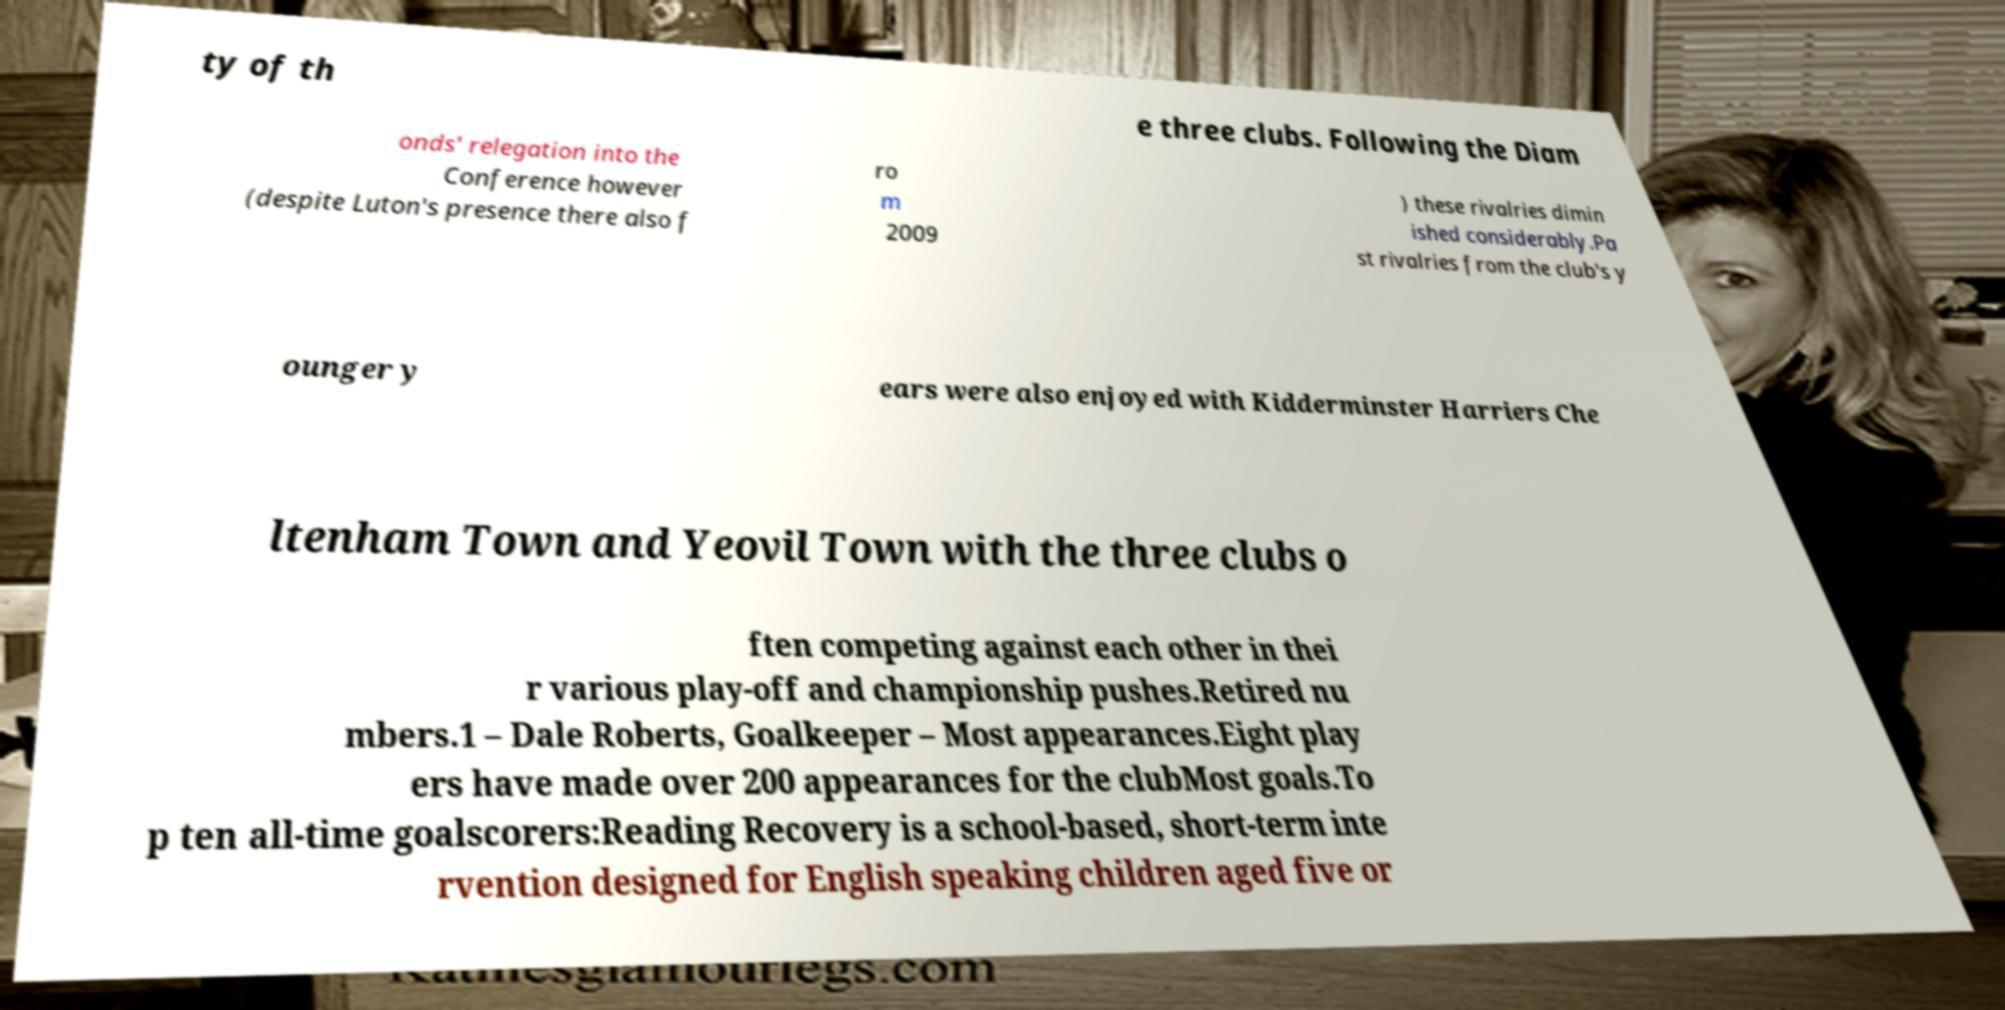For documentation purposes, I need the text within this image transcribed. Could you provide that? ty of th e three clubs. Following the Diam onds' relegation into the Conference however (despite Luton's presence there also f ro m 2009 ) these rivalries dimin ished considerably.Pa st rivalries from the club's y ounger y ears were also enjoyed with Kidderminster Harriers Che ltenham Town and Yeovil Town with the three clubs o ften competing against each other in thei r various play-off and championship pushes.Retired nu mbers.1 – Dale Roberts, Goalkeeper – Most appearances.Eight play ers have made over 200 appearances for the clubMost goals.To p ten all-time goalscorers:Reading Recovery is a school-based, short-term inte rvention designed for English speaking children aged five or 